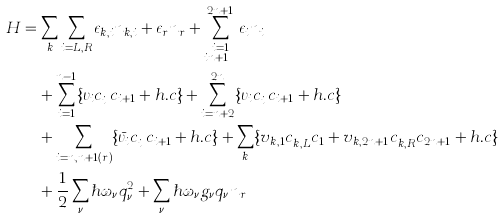<formula> <loc_0><loc_0><loc_500><loc_500>H & = \sum _ { k } \sum _ { i = L , R } \epsilon _ { k , i } n _ { k , i } + \epsilon _ { r } n _ { r } + \sum _ { \substack { i = 1 \\ i \neq n + 1 } } ^ { 2 n + 1 } \epsilon _ { i } n _ { i } \\ & \quad + \sum _ { i = 1 } ^ { n - 1 } \{ \upsilon _ { i } c _ { i } ^ { \dagger } c _ { i + 1 } + h . c \} + \sum _ { i = n + 2 } ^ { 2 n } \{ \upsilon _ { i } c _ { i } ^ { \dagger } c _ { i + 1 } + h . c \} \\ & \quad + \sum _ { i = n , n + 1 ( r ) } \{ \bar { \upsilon _ { i } } c _ { i } ^ { \dagger } c _ { i + 1 } + h . c \} + \sum _ { k } \{ v _ { k , 1 } c _ { k , L } ^ { \dagger } c _ { 1 } + v _ { k , 2 n + 1 } c _ { k , R } ^ { \dagger } c _ { 2 n + 1 } + h . c \} \\ & \quad + \frac { 1 } { 2 } \sum _ { \nu } \hbar { \omega } _ { \nu } q _ { \nu } ^ { 2 } + \sum _ { \nu } \hbar { \omega } _ { \nu } g _ { \nu } q _ { \nu } n _ { r }</formula> 